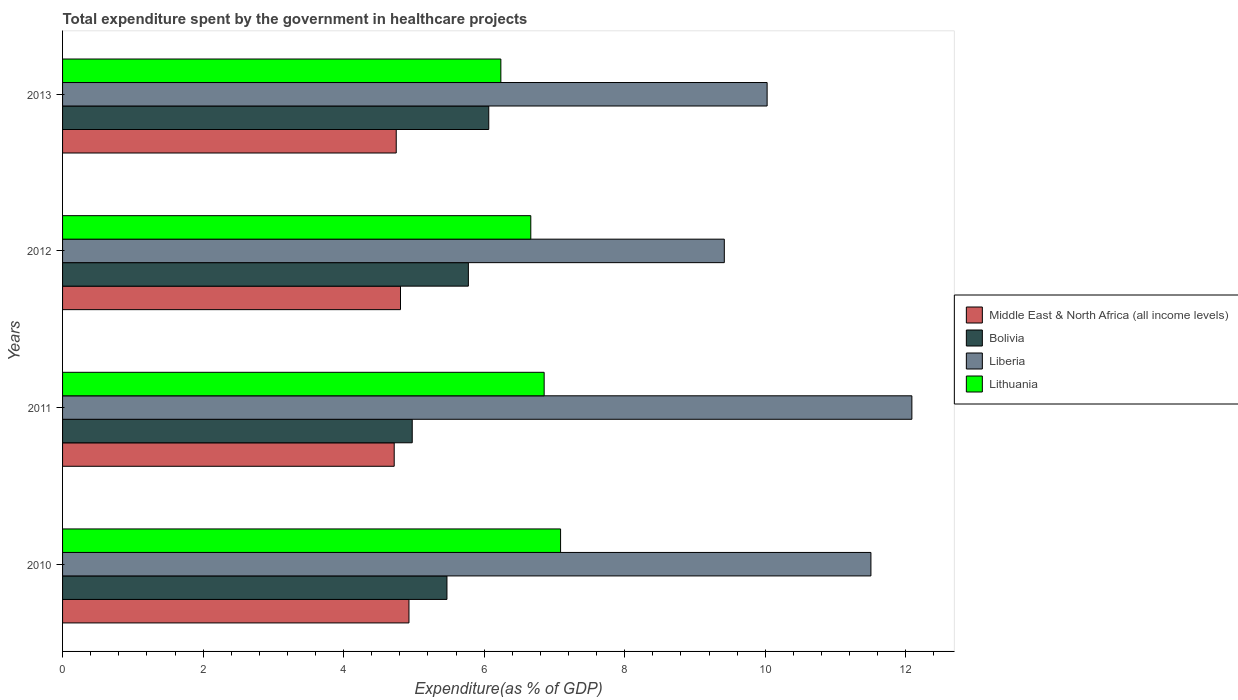How many groups of bars are there?
Offer a terse response. 4. What is the total expenditure spent by the government in healthcare projects in Middle East & North Africa (all income levels) in 2011?
Keep it short and to the point. 4.72. Across all years, what is the maximum total expenditure spent by the government in healthcare projects in Bolivia?
Your response must be concise. 6.07. Across all years, what is the minimum total expenditure spent by the government in healthcare projects in Middle East & North Africa (all income levels)?
Provide a short and direct response. 4.72. What is the total total expenditure spent by the government in healthcare projects in Liberia in the graph?
Your answer should be very brief. 43.03. What is the difference between the total expenditure spent by the government in healthcare projects in Middle East & North Africa (all income levels) in 2010 and that in 2012?
Your answer should be compact. 0.12. What is the difference between the total expenditure spent by the government in healthcare projects in Lithuania in 2013 and the total expenditure spent by the government in healthcare projects in Liberia in 2012?
Ensure brevity in your answer.  -3.18. What is the average total expenditure spent by the government in healthcare projects in Lithuania per year?
Make the answer very short. 6.71. In the year 2012, what is the difference between the total expenditure spent by the government in healthcare projects in Middle East & North Africa (all income levels) and total expenditure spent by the government in healthcare projects in Liberia?
Keep it short and to the point. -4.61. In how many years, is the total expenditure spent by the government in healthcare projects in Liberia greater than 6.4 %?
Make the answer very short. 4. What is the ratio of the total expenditure spent by the government in healthcare projects in Lithuania in 2010 to that in 2012?
Ensure brevity in your answer.  1.06. Is the total expenditure spent by the government in healthcare projects in Liberia in 2010 less than that in 2011?
Provide a succinct answer. Yes. What is the difference between the highest and the second highest total expenditure spent by the government in healthcare projects in Middle East & North Africa (all income levels)?
Keep it short and to the point. 0.12. What is the difference between the highest and the lowest total expenditure spent by the government in healthcare projects in Middle East & North Africa (all income levels)?
Ensure brevity in your answer.  0.21. In how many years, is the total expenditure spent by the government in healthcare projects in Middle East & North Africa (all income levels) greater than the average total expenditure spent by the government in healthcare projects in Middle East & North Africa (all income levels) taken over all years?
Ensure brevity in your answer.  2. Is the sum of the total expenditure spent by the government in healthcare projects in Bolivia in 2012 and 2013 greater than the maximum total expenditure spent by the government in healthcare projects in Middle East & North Africa (all income levels) across all years?
Your answer should be very brief. Yes. What does the 3rd bar from the bottom in 2013 represents?
Provide a succinct answer. Liberia. Is it the case that in every year, the sum of the total expenditure spent by the government in healthcare projects in Bolivia and total expenditure spent by the government in healthcare projects in Lithuania is greater than the total expenditure spent by the government in healthcare projects in Liberia?
Provide a short and direct response. No. Are all the bars in the graph horizontal?
Your answer should be very brief. Yes. Are the values on the major ticks of X-axis written in scientific E-notation?
Your answer should be very brief. No. Does the graph contain any zero values?
Your response must be concise. No. Where does the legend appear in the graph?
Keep it short and to the point. Center right. How many legend labels are there?
Give a very brief answer. 4. What is the title of the graph?
Keep it short and to the point. Total expenditure spent by the government in healthcare projects. What is the label or title of the X-axis?
Ensure brevity in your answer.  Expenditure(as % of GDP). What is the label or title of the Y-axis?
Your response must be concise. Years. What is the Expenditure(as % of GDP) in Middle East & North Africa (all income levels) in 2010?
Make the answer very short. 4.93. What is the Expenditure(as % of GDP) of Bolivia in 2010?
Ensure brevity in your answer.  5.47. What is the Expenditure(as % of GDP) of Liberia in 2010?
Your answer should be compact. 11.5. What is the Expenditure(as % of GDP) of Lithuania in 2010?
Provide a succinct answer. 7.09. What is the Expenditure(as % of GDP) of Middle East & North Africa (all income levels) in 2011?
Your response must be concise. 4.72. What is the Expenditure(as % of GDP) in Bolivia in 2011?
Offer a terse response. 4.98. What is the Expenditure(as % of GDP) in Liberia in 2011?
Ensure brevity in your answer.  12.09. What is the Expenditure(as % of GDP) in Lithuania in 2011?
Your answer should be very brief. 6.85. What is the Expenditure(as % of GDP) in Middle East & North Africa (all income levels) in 2012?
Your response must be concise. 4.81. What is the Expenditure(as % of GDP) of Bolivia in 2012?
Give a very brief answer. 5.77. What is the Expenditure(as % of GDP) in Liberia in 2012?
Give a very brief answer. 9.42. What is the Expenditure(as % of GDP) of Lithuania in 2012?
Make the answer very short. 6.66. What is the Expenditure(as % of GDP) in Middle East & North Africa (all income levels) in 2013?
Provide a short and direct response. 4.75. What is the Expenditure(as % of GDP) in Bolivia in 2013?
Offer a terse response. 6.07. What is the Expenditure(as % of GDP) in Liberia in 2013?
Provide a succinct answer. 10.03. What is the Expenditure(as % of GDP) of Lithuania in 2013?
Your answer should be very brief. 6.24. Across all years, what is the maximum Expenditure(as % of GDP) in Middle East & North Africa (all income levels)?
Your answer should be very brief. 4.93. Across all years, what is the maximum Expenditure(as % of GDP) of Bolivia?
Your answer should be compact. 6.07. Across all years, what is the maximum Expenditure(as % of GDP) of Liberia?
Offer a terse response. 12.09. Across all years, what is the maximum Expenditure(as % of GDP) of Lithuania?
Your answer should be compact. 7.09. Across all years, what is the minimum Expenditure(as % of GDP) in Middle East & North Africa (all income levels)?
Provide a succinct answer. 4.72. Across all years, what is the minimum Expenditure(as % of GDP) in Bolivia?
Provide a succinct answer. 4.98. Across all years, what is the minimum Expenditure(as % of GDP) in Liberia?
Keep it short and to the point. 9.42. Across all years, what is the minimum Expenditure(as % of GDP) in Lithuania?
Your answer should be compact. 6.24. What is the total Expenditure(as % of GDP) of Middle East & North Africa (all income levels) in the graph?
Give a very brief answer. 19.21. What is the total Expenditure(as % of GDP) in Bolivia in the graph?
Offer a very short reply. 22.29. What is the total Expenditure(as % of GDP) of Liberia in the graph?
Give a very brief answer. 43.03. What is the total Expenditure(as % of GDP) in Lithuania in the graph?
Provide a short and direct response. 26.84. What is the difference between the Expenditure(as % of GDP) of Middle East & North Africa (all income levels) in 2010 and that in 2011?
Offer a very short reply. 0.21. What is the difference between the Expenditure(as % of GDP) of Bolivia in 2010 and that in 2011?
Your answer should be very brief. 0.49. What is the difference between the Expenditure(as % of GDP) of Liberia in 2010 and that in 2011?
Make the answer very short. -0.58. What is the difference between the Expenditure(as % of GDP) of Lithuania in 2010 and that in 2011?
Provide a short and direct response. 0.23. What is the difference between the Expenditure(as % of GDP) of Middle East & North Africa (all income levels) in 2010 and that in 2012?
Your response must be concise. 0.12. What is the difference between the Expenditure(as % of GDP) in Bolivia in 2010 and that in 2012?
Provide a succinct answer. -0.3. What is the difference between the Expenditure(as % of GDP) in Liberia in 2010 and that in 2012?
Your response must be concise. 2.09. What is the difference between the Expenditure(as % of GDP) in Lithuania in 2010 and that in 2012?
Offer a very short reply. 0.42. What is the difference between the Expenditure(as % of GDP) of Middle East & North Africa (all income levels) in 2010 and that in 2013?
Give a very brief answer. 0.18. What is the difference between the Expenditure(as % of GDP) in Bolivia in 2010 and that in 2013?
Ensure brevity in your answer.  -0.6. What is the difference between the Expenditure(as % of GDP) in Liberia in 2010 and that in 2013?
Make the answer very short. 1.48. What is the difference between the Expenditure(as % of GDP) in Lithuania in 2010 and that in 2013?
Offer a very short reply. 0.85. What is the difference between the Expenditure(as % of GDP) of Middle East & North Africa (all income levels) in 2011 and that in 2012?
Keep it short and to the point. -0.09. What is the difference between the Expenditure(as % of GDP) of Bolivia in 2011 and that in 2012?
Offer a terse response. -0.8. What is the difference between the Expenditure(as % of GDP) in Liberia in 2011 and that in 2012?
Keep it short and to the point. 2.67. What is the difference between the Expenditure(as % of GDP) of Lithuania in 2011 and that in 2012?
Your answer should be very brief. 0.19. What is the difference between the Expenditure(as % of GDP) in Middle East & North Africa (all income levels) in 2011 and that in 2013?
Provide a succinct answer. -0.03. What is the difference between the Expenditure(as % of GDP) of Bolivia in 2011 and that in 2013?
Ensure brevity in your answer.  -1.09. What is the difference between the Expenditure(as % of GDP) of Liberia in 2011 and that in 2013?
Give a very brief answer. 2.06. What is the difference between the Expenditure(as % of GDP) in Lithuania in 2011 and that in 2013?
Your response must be concise. 0.62. What is the difference between the Expenditure(as % of GDP) in Middle East & North Africa (all income levels) in 2012 and that in 2013?
Provide a short and direct response. 0.06. What is the difference between the Expenditure(as % of GDP) in Bolivia in 2012 and that in 2013?
Your answer should be compact. -0.29. What is the difference between the Expenditure(as % of GDP) in Liberia in 2012 and that in 2013?
Offer a very short reply. -0.61. What is the difference between the Expenditure(as % of GDP) in Lithuania in 2012 and that in 2013?
Provide a short and direct response. 0.43. What is the difference between the Expenditure(as % of GDP) in Middle East & North Africa (all income levels) in 2010 and the Expenditure(as % of GDP) in Bolivia in 2011?
Keep it short and to the point. -0.05. What is the difference between the Expenditure(as % of GDP) in Middle East & North Africa (all income levels) in 2010 and the Expenditure(as % of GDP) in Liberia in 2011?
Offer a terse response. -7.16. What is the difference between the Expenditure(as % of GDP) of Middle East & North Africa (all income levels) in 2010 and the Expenditure(as % of GDP) of Lithuania in 2011?
Your answer should be compact. -1.92. What is the difference between the Expenditure(as % of GDP) of Bolivia in 2010 and the Expenditure(as % of GDP) of Liberia in 2011?
Keep it short and to the point. -6.62. What is the difference between the Expenditure(as % of GDP) of Bolivia in 2010 and the Expenditure(as % of GDP) of Lithuania in 2011?
Your answer should be very brief. -1.38. What is the difference between the Expenditure(as % of GDP) of Liberia in 2010 and the Expenditure(as % of GDP) of Lithuania in 2011?
Offer a terse response. 4.65. What is the difference between the Expenditure(as % of GDP) in Middle East & North Africa (all income levels) in 2010 and the Expenditure(as % of GDP) in Bolivia in 2012?
Your response must be concise. -0.85. What is the difference between the Expenditure(as % of GDP) of Middle East & North Africa (all income levels) in 2010 and the Expenditure(as % of GDP) of Liberia in 2012?
Keep it short and to the point. -4.49. What is the difference between the Expenditure(as % of GDP) of Middle East & North Africa (all income levels) in 2010 and the Expenditure(as % of GDP) of Lithuania in 2012?
Make the answer very short. -1.73. What is the difference between the Expenditure(as % of GDP) of Bolivia in 2010 and the Expenditure(as % of GDP) of Liberia in 2012?
Your answer should be very brief. -3.95. What is the difference between the Expenditure(as % of GDP) of Bolivia in 2010 and the Expenditure(as % of GDP) of Lithuania in 2012?
Offer a terse response. -1.19. What is the difference between the Expenditure(as % of GDP) of Liberia in 2010 and the Expenditure(as % of GDP) of Lithuania in 2012?
Your answer should be very brief. 4.84. What is the difference between the Expenditure(as % of GDP) in Middle East & North Africa (all income levels) in 2010 and the Expenditure(as % of GDP) in Bolivia in 2013?
Offer a very short reply. -1.14. What is the difference between the Expenditure(as % of GDP) of Middle East & North Africa (all income levels) in 2010 and the Expenditure(as % of GDP) of Liberia in 2013?
Give a very brief answer. -5.1. What is the difference between the Expenditure(as % of GDP) of Middle East & North Africa (all income levels) in 2010 and the Expenditure(as % of GDP) of Lithuania in 2013?
Your response must be concise. -1.31. What is the difference between the Expenditure(as % of GDP) of Bolivia in 2010 and the Expenditure(as % of GDP) of Liberia in 2013?
Ensure brevity in your answer.  -4.56. What is the difference between the Expenditure(as % of GDP) in Bolivia in 2010 and the Expenditure(as % of GDP) in Lithuania in 2013?
Make the answer very short. -0.77. What is the difference between the Expenditure(as % of GDP) of Liberia in 2010 and the Expenditure(as % of GDP) of Lithuania in 2013?
Your answer should be compact. 5.27. What is the difference between the Expenditure(as % of GDP) of Middle East & North Africa (all income levels) in 2011 and the Expenditure(as % of GDP) of Bolivia in 2012?
Your answer should be very brief. -1.06. What is the difference between the Expenditure(as % of GDP) of Middle East & North Africa (all income levels) in 2011 and the Expenditure(as % of GDP) of Liberia in 2012?
Offer a terse response. -4.7. What is the difference between the Expenditure(as % of GDP) in Middle East & North Africa (all income levels) in 2011 and the Expenditure(as % of GDP) in Lithuania in 2012?
Your response must be concise. -1.94. What is the difference between the Expenditure(as % of GDP) of Bolivia in 2011 and the Expenditure(as % of GDP) of Liberia in 2012?
Offer a terse response. -4.44. What is the difference between the Expenditure(as % of GDP) in Bolivia in 2011 and the Expenditure(as % of GDP) in Lithuania in 2012?
Make the answer very short. -1.69. What is the difference between the Expenditure(as % of GDP) of Liberia in 2011 and the Expenditure(as % of GDP) of Lithuania in 2012?
Provide a succinct answer. 5.42. What is the difference between the Expenditure(as % of GDP) in Middle East & North Africa (all income levels) in 2011 and the Expenditure(as % of GDP) in Bolivia in 2013?
Provide a short and direct response. -1.35. What is the difference between the Expenditure(as % of GDP) of Middle East & North Africa (all income levels) in 2011 and the Expenditure(as % of GDP) of Liberia in 2013?
Keep it short and to the point. -5.31. What is the difference between the Expenditure(as % of GDP) of Middle East & North Africa (all income levels) in 2011 and the Expenditure(as % of GDP) of Lithuania in 2013?
Ensure brevity in your answer.  -1.52. What is the difference between the Expenditure(as % of GDP) of Bolivia in 2011 and the Expenditure(as % of GDP) of Liberia in 2013?
Provide a short and direct response. -5.05. What is the difference between the Expenditure(as % of GDP) of Bolivia in 2011 and the Expenditure(as % of GDP) of Lithuania in 2013?
Provide a succinct answer. -1.26. What is the difference between the Expenditure(as % of GDP) in Liberia in 2011 and the Expenditure(as % of GDP) in Lithuania in 2013?
Offer a very short reply. 5.85. What is the difference between the Expenditure(as % of GDP) of Middle East & North Africa (all income levels) in 2012 and the Expenditure(as % of GDP) of Bolivia in 2013?
Your answer should be very brief. -1.26. What is the difference between the Expenditure(as % of GDP) of Middle East & North Africa (all income levels) in 2012 and the Expenditure(as % of GDP) of Liberia in 2013?
Keep it short and to the point. -5.22. What is the difference between the Expenditure(as % of GDP) of Middle East & North Africa (all income levels) in 2012 and the Expenditure(as % of GDP) of Lithuania in 2013?
Your answer should be compact. -1.43. What is the difference between the Expenditure(as % of GDP) of Bolivia in 2012 and the Expenditure(as % of GDP) of Liberia in 2013?
Provide a short and direct response. -4.25. What is the difference between the Expenditure(as % of GDP) in Bolivia in 2012 and the Expenditure(as % of GDP) in Lithuania in 2013?
Ensure brevity in your answer.  -0.46. What is the difference between the Expenditure(as % of GDP) in Liberia in 2012 and the Expenditure(as % of GDP) in Lithuania in 2013?
Offer a terse response. 3.18. What is the average Expenditure(as % of GDP) of Middle East & North Africa (all income levels) per year?
Your response must be concise. 4.8. What is the average Expenditure(as % of GDP) in Bolivia per year?
Provide a succinct answer. 5.57. What is the average Expenditure(as % of GDP) of Liberia per year?
Your answer should be compact. 10.76. What is the average Expenditure(as % of GDP) of Lithuania per year?
Provide a succinct answer. 6.71. In the year 2010, what is the difference between the Expenditure(as % of GDP) in Middle East & North Africa (all income levels) and Expenditure(as % of GDP) in Bolivia?
Your answer should be compact. -0.54. In the year 2010, what is the difference between the Expenditure(as % of GDP) in Middle East & North Africa (all income levels) and Expenditure(as % of GDP) in Liberia?
Offer a very short reply. -6.57. In the year 2010, what is the difference between the Expenditure(as % of GDP) in Middle East & North Africa (all income levels) and Expenditure(as % of GDP) in Lithuania?
Provide a short and direct response. -2.16. In the year 2010, what is the difference between the Expenditure(as % of GDP) in Bolivia and Expenditure(as % of GDP) in Liberia?
Your answer should be very brief. -6.03. In the year 2010, what is the difference between the Expenditure(as % of GDP) in Bolivia and Expenditure(as % of GDP) in Lithuania?
Your answer should be very brief. -1.62. In the year 2010, what is the difference between the Expenditure(as % of GDP) of Liberia and Expenditure(as % of GDP) of Lithuania?
Your answer should be compact. 4.42. In the year 2011, what is the difference between the Expenditure(as % of GDP) of Middle East & North Africa (all income levels) and Expenditure(as % of GDP) of Bolivia?
Ensure brevity in your answer.  -0.26. In the year 2011, what is the difference between the Expenditure(as % of GDP) of Middle East & North Africa (all income levels) and Expenditure(as % of GDP) of Liberia?
Your answer should be very brief. -7.37. In the year 2011, what is the difference between the Expenditure(as % of GDP) in Middle East & North Africa (all income levels) and Expenditure(as % of GDP) in Lithuania?
Keep it short and to the point. -2.13. In the year 2011, what is the difference between the Expenditure(as % of GDP) in Bolivia and Expenditure(as % of GDP) in Liberia?
Make the answer very short. -7.11. In the year 2011, what is the difference between the Expenditure(as % of GDP) of Bolivia and Expenditure(as % of GDP) of Lithuania?
Provide a short and direct response. -1.88. In the year 2011, what is the difference between the Expenditure(as % of GDP) of Liberia and Expenditure(as % of GDP) of Lithuania?
Provide a short and direct response. 5.23. In the year 2012, what is the difference between the Expenditure(as % of GDP) in Middle East & North Africa (all income levels) and Expenditure(as % of GDP) in Bolivia?
Your response must be concise. -0.97. In the year 2012, what is the difference between the Expenditure(as % of GDP) in Middle East & North Africa (all income levels) and Expenditure(as % of GDP) in Liberia?
Provide a succinct answer. -4.61. In the year 2012, what is the difference between the Expenditure(as % of GDP) in Middle East & North Africa (all income levels) and Expenditure(as % of GDP) in Lithuania?
Offer a terse response. -1.85. In the year 2012, what is the difference between the Expenditure(as % of GDP) of Bolivia and Expenditure(as % of GDP) of Liberia?
Give a very brief answer. -3.64. In the year 2012, what is the difference between the Expenditure(as % of GDP) of Bolivia and Expenditure(as % of GDP) of Lithuania?
Offer a very short reply. -0.89. In the year 2012, what is the difference between the Expenditure(as % of GDP) of Liberia and Expenditure(as % of GDP) of Lithuania?
Make the answer very short. 2.75. In the year 2013, what is the difference between the Expenditure(as % of GDP) of Middle East & North Africa (all income levels) and Expenditure(as % of GDP) of Bolivia?
Your answer should be compact. -1.32. In the year 2013, what is the difference between the Expenditure(as % of GDP) in Middle East & North Africa (all income levels) and Expenditure(as % of GDP) in Liberia?
Provide a short and direct response. -5.28. In the year 2013, what is the difference between the Expenditure(as % of GDP) of Middle East & North Africa (all income levels) and Expenditure(as % of GDP) of Lithuania?
Provide a succinct answer. -1.49. In the year 2013, what is the difference between the Expenditure(as % of GDP) of Bolivia and Expenditure(as % of GDP) of Liberia?
Your response must be concise. -3.96. In the year 2013, what is the difference between the Expenditure(as % of GDP) in Bolivia and Expenditure(as % of GDP) in Lithuania?
Keep it short and to the point. -0.17. In the year 2013, what is the difference between the Expenditure(as % of GDP) in Liberia and Expenditure(as % of GDP) in Lithuania?
Your answer should be very brief. 3.79. What is the ratio of the Expenditure(as % of GDP) in Middle East & North Africa (all income levels) in 2010 to that in 2011?
Provide a short and direct response. 1.04. What is the ratio of the Expenditure(as % of GDP) in Bolivia in 2010 to that in 2011?
Offer a very short reply. 1.1. What is the ratio of the Expenditure(as % of GDP) in Liberia in 2010 to that in 2011?
Your answer should be compact. 0.95. What is the ratio of the Expenditure(as % of GDP) of Lithuania in 2010 to that in 2011?
Provide a short and direct response. 1.03. What is the ratio of the Expenditure(as % of GDP) of Middle East & North Africa (all income levels) in 2010 to that in 2012?
Provide a short and direct response. 1.03. What is the ratio of the Expenditure(as % of GDP) of Bolivia in 2010 to that in 2012?
Keep it short and to the point. 0.95. What is the ratio of the Expenditure(as % of GDP) in Liberia in 2010 to that in 2012?
Make the answer very short. 1.22. What is the ratio of the Expenditure(as % of GDP) in Lithuania in 2010 to that in 2012?
Offer a very short reply. 1.06. What is the ratio of the Expenditure(as % of GDP) in Middle East & North Africa (all income levels) in 2010 to that in 2013?
Provide a succinct answer. 1.04. What is the ratio of the Expenditure(as % of GDP) in Bolivia in 2010 to that in 2013?
Your answer should be compact. 0.9. What is the ratio of the Expenditure(as % of GDP) in Liberia in 2010 to that in 2013?
Ensure brevity in your answer.  1.15. What is the ratio of the Expenditure(as % of GDP) in Lithuania in 2010 to that in 2013?
Offer a terse response. 1.14. What is the ratio of the Expenditure(as % of GDP) in Middle East & North Africa (all income levels) in 2011 to that in 2012?
Provide a short and direct response. 0.98. What is the ratio of the Expenditure(as % of GDP) of Bolivia in 2011 to that in 2012?
Offer a terse response. 0.86. What is the ratio of the Expenditure(as % of GDP) in Liberia in 2011 to that in 2012?
Your answer should be compact. 1.28. What is the ratio of the Expenditure(as % of GDP) of Lithuania in 2011 to that in 2012?
Your answer should be compact. 1.03. What is the ratio of the Expenditure(as % of GDP) of Bolivia in 2011 to that in 2013?
Ensure brevity in your answer.  0.82. What is the ratio of the Expenditure(as % of GDP) of Liberia in 2011 to that in 2013?
Your answer should be compact. 1.21. What is the ratio of the Expenditure(as % of GDP) of Lithuania in 2011 to that in 2013?
Provide a short and direct response. 1.1. What is the ratio of the Expenditure(as % of GDP) of Middle East & North Africa (all income levels) in 2012 to that in 2013?
Provide a short and direct response. 1.01. What is the ratio of the Expenditure(as % of GDP) of Bolivia in 2012 to that in 2013?
Keep it short and to the point. 0.95. What is the ratio of the Expenditure(as % of GDP) in Liberia in 2012 to that in 2013?
Keep it short and to the point. 0.94. What is the ratio of the Expenditure(as % of GDP) of Lithuania in 2012 to that in 2013?
Provide a short and direct response. 1.07. What is the difference between the highest and the second highest Expenditure(as % of GDP) of Middle East & North Africa (all income levels)?
Your answer should be compact. 0.12. What is the difference between the highest and the second highest Expenditure(as % of GDP) in Bolivia?
Make the answer very short. 0.29. What is the difference between the highest and the second highest Expenditure(as % of GDP) of Liberia?
Ensure brevity in your answer.  0.58. What is the difference between the highest and the second highest Expenditure(as % of GDP) in Lithuania?
Your response must be concise. 0.23. What is the difference between the highest and the lowest Expenditure(as % of GDP) of Middle East & North Africa (all income levels)?
Your answer should be very brief. 0.21. What is the difference between the highest and the lowest Expenditure(as % of GDP) of Bolivia?
Offer a very short reply. 1.09. What is the difference between the highest and the lowest Expenditure(as % of GDP) in Liberia?
Your response must be concise. 2.67. What is the difference between the highest and the lowest Expenditure(as % of GDP) in Lithuania?
Offer a very short reply. 0.85. 